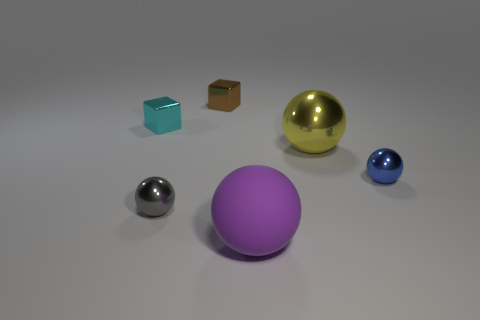Is there anything else that is the same shape as the purple object? Indeed, there is a golden object to the right of the purple one that shares the same spherical shape. The reflective surfaces and sizes appear similar, suggesting they could belong to a set despite their different colors. 